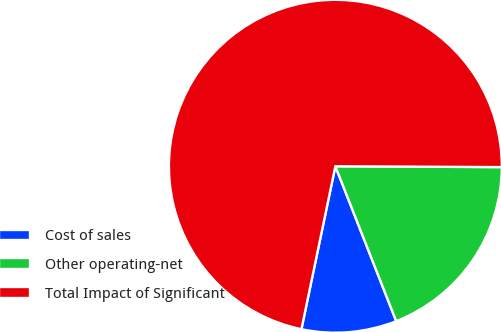Convert chart to OTSL. <chart><loc_0><loc_0><loc_500><loc_500><pie_chart><fcel>Cost of sales<fcel>Other operating-net<fcel>Total Impact of Significant<nl><fcel>9.23%<fcel>18.96%<fcel>71.82%<nl></chart> 